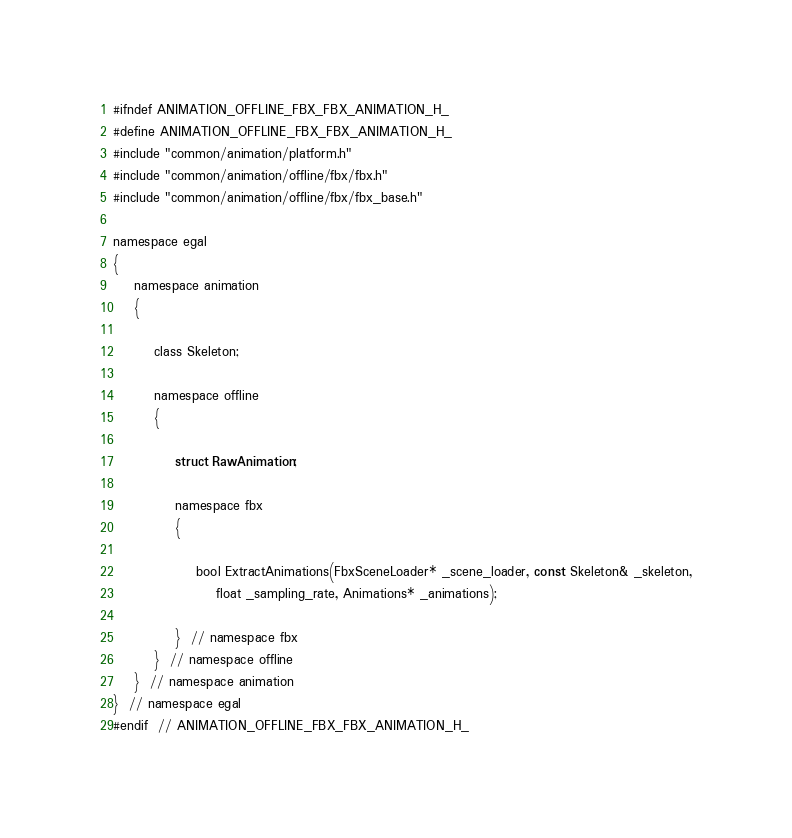<code> <loc_0><loc_0><loc_500><loc_500><_C_>
#ifndef ANIMATION_OFFLINE_FBX_FBX_ANIMATION_H_
#define ANIMATION_OFFLINE_FBX_FBX_ANIMATION_H_
#include "common/animation/platform.h"
#include "common/animation/offline/fbx/fbx.h"
#include "common/animation/offline/fbx/fbx_base.h"

namespace egal
{
	namespace animation
	{

		class Skeleton;

		namespace offline
		{

			struct RawAnimation;

			namespace fbx
			{

				bool ExtractAnimations(FbxSceneLoader* _scene_loader, const Skeleton& _skeleton,
					float _sampling_rate, Animations* _animations);

			}  // namespace fbx
		}  // namespace offline
	}  // namespace animation
}  // namespace egal
#endif  // ANIMATION_OFFLINE_FBX_FBX_ANIMATION_H_
</code> 